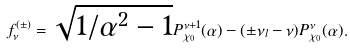<formula> <loc_0><loc_0><loc_500><loc_500>f _ { \nu } ^ { ( \pm ) } = \sqrt { 1 / \alpha ^ { 2 } - 1 } P _ { \chi _ { 0 } } ^ { \nu + 1 } ( \alpha ) - ( \pm \nu _ { l } - \nu ) P _ { \chi _ { 0 } } ^ { \nu } ( \alpha ) .</formula> 